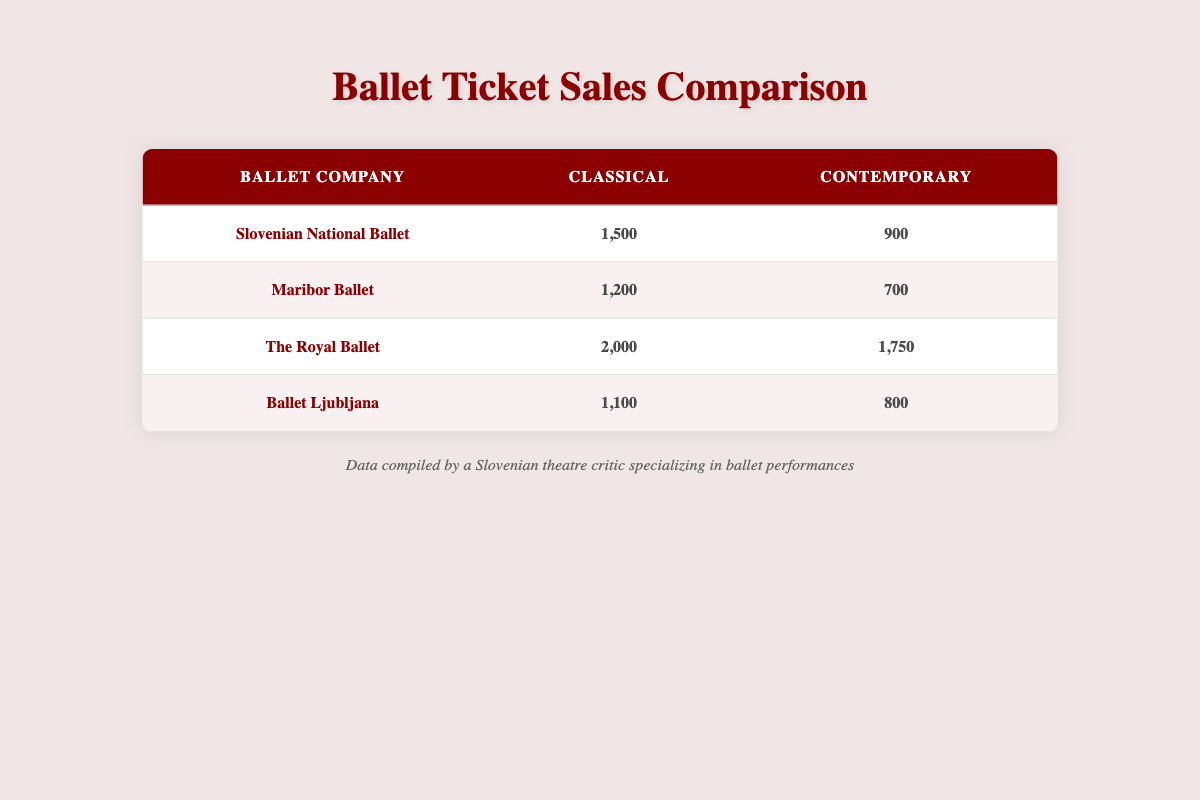What is the total ticket sales for the Slovenian National Ballet? The ticket sales for the Slovenian National Ballet can be found by adding the sales of both performance types. Classical sales are 1500, and Contemporary sales are 900. Adding these gives 1500 + 900 = 2400.
Answer: 2400 Which ballet company had the highest ticket sales for Classical performances? The table lists the Classical ticket sales for each ballet company. Slovenian National Ballet has 1500, Maribor Ballet has 1200, The Royal Ballet has 2000, and Ballet Ljubljana has 1100. The highest value is for The Royal Ballet with sales of 2000.
Answer: The Royal Ballet How many more ticket sales did The Royal Ballet have compared to Ballet Ljubljana in Contemporary performances? The Contemporary ticket sales for The Royal Ballet are 1750, while for Ballet Ljubljana, it is 800. The difference is calculated by subtracting 800 from 1750, which results in 1750 - 800 = 950.
Answer: 950 Is it true that Ballet Ljubljana sold more tickets for Classical performances than Maribor Ballet? Ballet Ljubljana's Classical ticket sales are 1100, while Maribor Ballet's are 1200. Since 1100 is less than 1200, the statement is false.
Answer: No What is the average ticket sales for Classical performances across all companies? To find the average, first sum the Classical ticket sales: 1500 (Slovenian National Ballet) + 1200 (Maribor Ballet) + 2000 (The Royal Ballet) + 1100 (Ballet Ljubljana) = 5800. Then divide by the number of companies, which is 4: 5800 / 4 = 1450.
Answer: 1450 